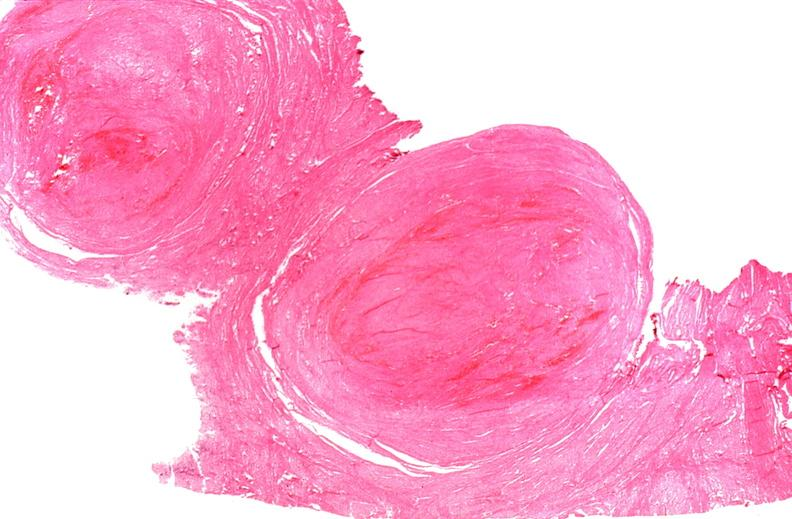does intramural one lesion show uterus, leiomyomas?
Answer the question using a single word or phrase. No 